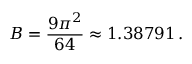<formula> <loc_0><loc_0><loc_500><loc_500>B = { \frac { 9 \pi ^ { 2 } } { 6 4 } } \approx 1 . 3 8 7 9 1 \, .</formula> 